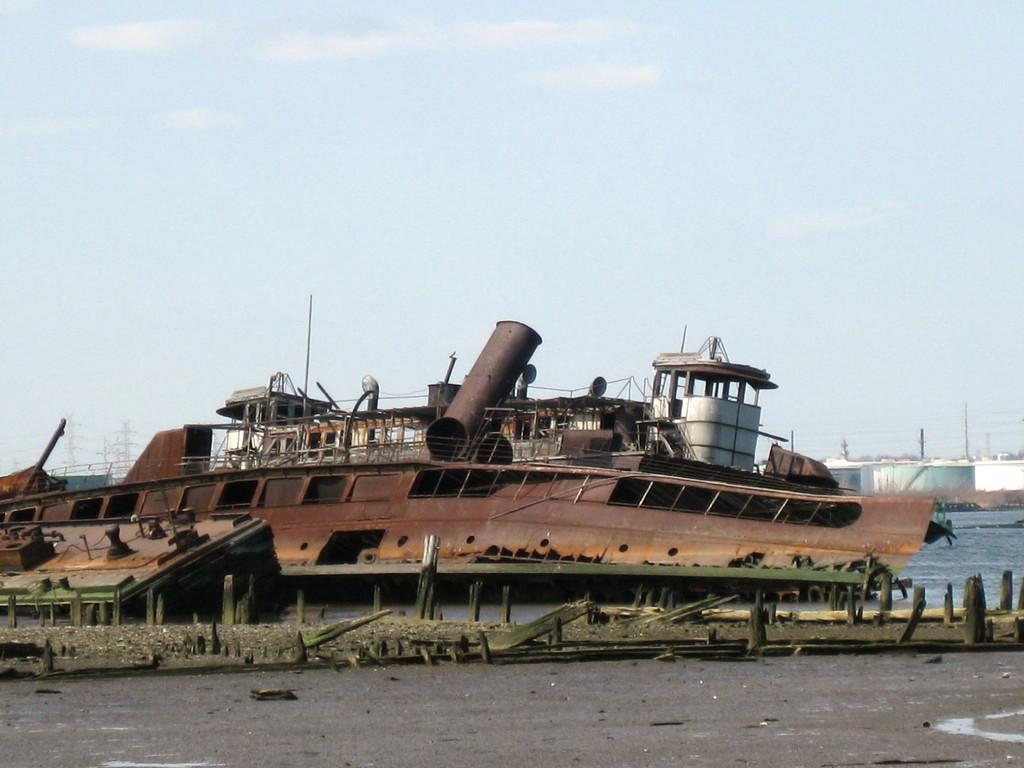What is the main subject of the image? The main subject of the image is a ship. Where is the ship located in the image? The ship is on the water in the image. What can be seen in the background of the image? In the background of the image, there are poles, wires, and the sky. What else is present on the ground in the image? There are other objects on the ground in the image. How many cattle can be seen grazing on the ship in the image? There are no cattle present in the image, as it features a ship on the water with background elements and other objects on the ground. What angle is the ship positioned at in the image? The angle at which the ship is positioned cannot be determined from the image alone, as it only provides a two-dimensional representation. 